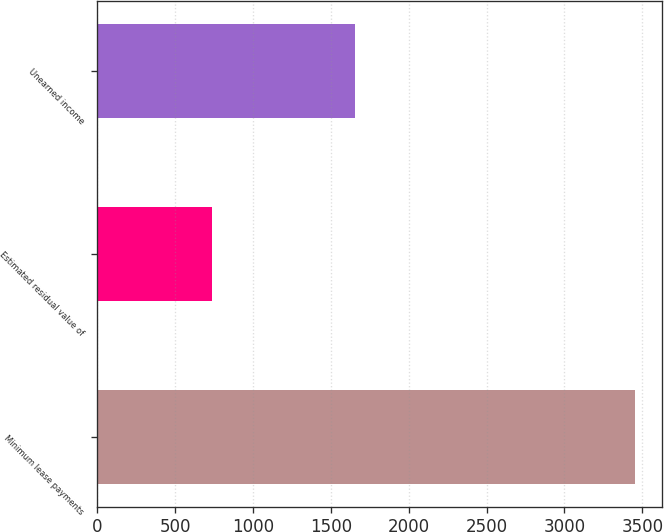<chart> <loc_0><loc_0><loc_500><loc_500><bar_chart><fcel>Minimum lease payments<fcel>Estimated residual value of<fcel>Unearned income<nl><fcel>3451<fcel>735<fcel>1658<nl></chart> 